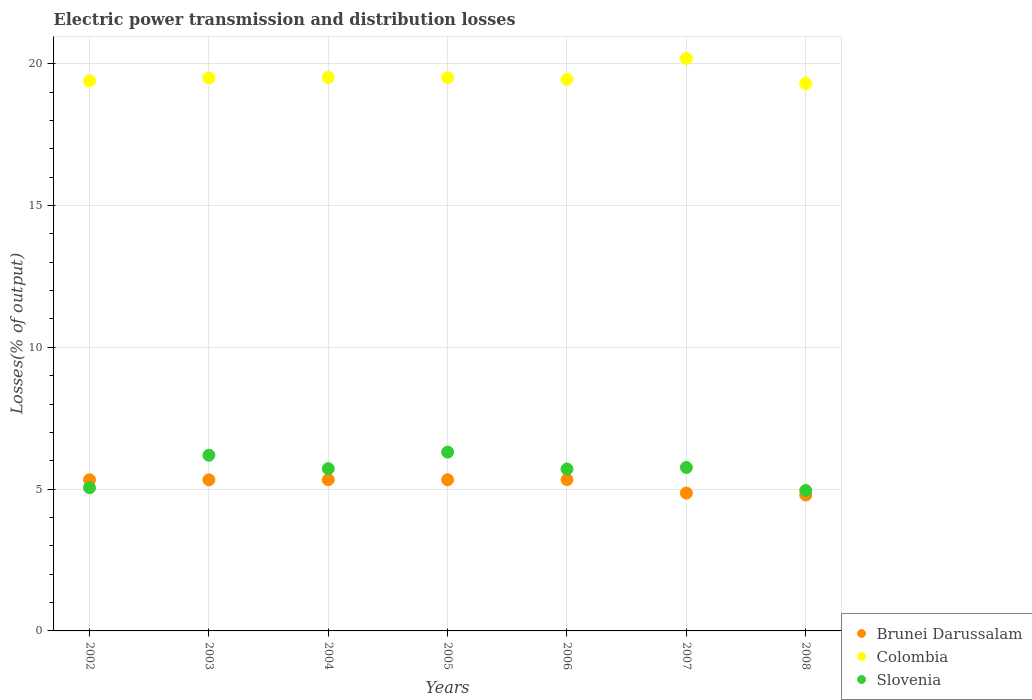How many different coloured dotlines are there?
Provide a short and direct response. 3. Is the number of dotlines equal to the number of legend labels?
Your answer should be compact. Yes. What is the electric power transmission and distribution losses in Colombia in 2007?
Provide a succinct answer. 20.19. Across all years, what is the maximum electric power transmission and distribution losses in Slovenia?
Offer a very short reply. 6.3. Across all years, what is the minimum electric power transmission and distribution losses in Colombia?
Offer a very short reply. 19.3. What is the total electric power transmission and distribution losses in Colombia in the graph?
Your answer should be compact. 136.85. What is the difference between the electric power transmission and distribution losses in Colombia in 2006 and that in 2008?
Provide a short and direct response. 0.14. What is the difference between the electric power transmission and distribution losses in Brunei Darussalam in 2003 and the electric power transmission and distribution losses in Slovenia in 2007?
Your response must be concise. -0.44. What is the average electric power transmission and distribution losses in Slovenia per year?
Make the answer very short. 5.67. In the year 2005, what is the difference between the electric power transmission and distribution losses in Slovenia and electric power transmission and distribution losses in Brunei Darussalam?
Give a very brief answer. 0.97. In how many years, is the electric power transmission and distribution losses in Slovenia greater than 14 %?
Offer a terse response. 0. What is the ratio of the electric power transmission and distribution losses in Colombia in 2002 to that in 2008?
Your answer should be very brief. 1. What is the difference between the highest and the second highest electric power transmission and distribution losses in Slovenia?
Ensure brevity in your answer.  0.11. What is the difference between the highest and the lowest electric power transmission and distribution losses in Colombia?
Your response must be concise. 0.88. Is it the case that in every year, the sum of the electric power transmission and distribution losses in Slovenia and electric power transmission and distribution losses in Brunei Darussalam  is greater than the electric power transmission and distribution losses in Colombia?
Give a very brief answer. No. Is the electric power transmission and distribution losses in Colombia strictly less than the electric power transmission and distribution losses in Slovenia over the years?
Offer a very short reply. No. What is the difference between two consecutive major ticks on the Y-axis?
Give a very brief answer. 5. Are the values on the major ticks of Y-axis written in scientific E-notation?
Make the answer very short. No. Does the graph contain grids?
Your response must be concise. Yes. What is the title of the graph?
Offer a very short reply. Electric power transmission and distribution losses. What is the label or title of the Y-axis?
Your answer should be very brief. Losses(% of output). What is the Losses(% of output) in Brunei Darussalam in 2002?
Keep it short and to the point. 5.33. What is the Losses(% of output) of Colombia in 2002?
Make the answer very short. 19.4. What is the Losses(% of output) of Slovenia in 2002?
Give a very brief answer. 5.05. What is the Losses(% of output) in Brunei Darussalam in 2003?
Offer a terse response. 5.33. What is the Losses(% of output) of Colombia in 2003?
Offer a terse response. 19.49. What is the Losses(% of output) of Slovenia in 2003?
Offer a very short reply. 6.19. What is the Losses(% of output) in Brunei Darussalam in 2004?
Provide a short and direct response. 5.33. What is the Losses(% of output) in Colombia in 2004?
Offer a terse response. 19.52. What is the Losses(% of output) in Slovenia in 2004?
Your response must be concise. 5.72. What is the Losses(% of output) of Brunei Darussalam in 2005?
Your answer should be compact. 5.33. What is the Losses(% of output) of Colombia in 2005?
Offer a terse response. 19.51. What is the Losses(% of output) of Slovenia in 2005?
Ensure brevity in your answer.  6.3. What is the Losses(% of output) of Brunei Darussalam in 2006?
Make the answer very short. 5.34. What is the Losses(% of output) in Colombia in 2006?
Your answer should be very brief. 19.45. What is the Losses(% of output) in Slovenia in 2006?
Your answer should be compact. 5.71. What is the Losses(% of output) in Brunei Darussalam in 2007?
Provide a succinct answer. 4.86. What is the Losses(% of output) of Colombia in 2007?
Your response must be concise. 20.19. What is the Losses(% of output) of Slovenia in 2007?
Keep it short and to the point. 5.76. What is the Losses(% of output) in Brunei Darussalam in 2008?
Offer a very short reply. 4.79. What is the Losses(% of output) in Colombia in 2008?
Offer a very short reply. 19.3. What is the Losses(% of output) of Slovenia in 2008?
Ensure brevity in your answer.  4.95. Across all years, what is the maximum Losses(% of output) of Brunei Darussalam?
Make the answer very short. 5.34. Across all years, what is the maximum Losses(% of output) in Colombia?
Offer a terse response. 20.19. Across all years, what is the maximum Losses(% of output) in Slovenia?
Provide a succinct answer. 6.3. Across all years, what is the minimum Losses(% of output) of Brunei Darussalam?
Give a very brief answer. 4.79. Across all years, what is the minimum Losses(% of output) of Colombia?
Your answer should be compact. 19.3. Across all years, what is the minimum Losses(% of output) of Slovenia?
Provide a succinct answer. 4.95. What is the total Losses(% of output) in Brunei Darussalam in the graph?
Offer a very short reply. 36.31. What is the total Losses(% of output) in Colombia in the graph?
Offer a very short reply. 136.85. What is the total Losses(% of output) in Slovenia in the graph?
Make the answer very short. 39.69. What is the difference between the Losses(% of output) of Brunei Darussalam in 2002 and that in 2003?
Ensure brevity in your answer.  0. What is the difference between the Losses(% of output) of Colombia in 2002 and that in 2003?
Provide a succinct answer. -0.09. What is the difference between the Losses(% of output) in Slovenia in 2002 and that in 2003?
Ensure brevity in your answer.  -1.15. What is the difference between the Losses(% of output) of Colombia in 2002 and that in 2004?
Your answer should be very brief. -0.12. What is the difference between the Losses(% of output) in Slovenia in 2002 and that in 2004?
Provide a succinct answer. -0.67. What is the difference between the Losses(% of output) of Brunei Darussalam in 2002 and that in 2005?
Keep it short and to the point. 0. What is the difference between the Losses(% of output) in Colombia in 2002 and that in 2005?
Keep it short and to the point. -0.11. What is the difference between the Losses(% of output) in Slovenia in 2002 and that in 2005?
Ensure brevity in your answer.  -1.26. What is the difference between the Losses(% of output) in Brunei Darussalam in 2002 and that in 2006?
Your response must be concise. -0.01. What is the difference between the Losses(% of output) of Colombia in 2002 and that in 2006?
Offer a very short reply. -0.05. What is the difference between the Losses(% of output) in Slovenia in 2002 and that in 2006?
Provide a succinct answer. -0.66. What is the difference between the Losses(% of output) in Brunei Darussalam in 2002 and that in 2007?
Offer a very short reply. 0.47. What is the difference between the Losses(% of output) of Colombia in 2002 and that in 2007?
Your answer should be very brief. -0.79. What is the difference between the Losses(% of output) of Slovenia in 2002 and that in 2007?
Give a very brief answer. -0.71. What is the difference between the Losses(% of output) of Brunei Darussalam in 2002 and that in 2008?
Offer a very short reply. 0.54. What is the difference between the Losses(% of output) of Colombia in 2002 and that in 2008?
Keep it short and to the point. 0.09. What is the difference between the Losses(% of output) in Slovenia in 2002 and that in 2008?
Ensure brevity in your answer.  0.1. What is the difference between the Losses(% of output) of Brunei Darussalam in 2003 and that in 2004?
Keep it short and to the point. -0. What is the difference between the Losses(% of output) of Colombia in 2003 and that in 2004?
Offer a very short reply. -0.03. What is the difference between the Losses(% of output) of Slovenia in 2003 and that in 2004?
Provide a succinct answer. 0.47. What is the difference between the Losses(% of output) of Brunei Darussalam in 2003 and that in 2005?
Ensure brevity in your answer.  -0. What is the difference between the Losses(% of output) of Colombia in 2003 and that in 2005?
Ensure brevity in your answer.  -0.02. What is the difference between the Losses(% of output) of Slovenia in 2003 and that in 2005?
Provide a succinct answer. -0.11. What is the difference between the Losses(% of output) in Brunei Darussalam in 2003 and that in 2006?
Offer a terse response. -0.01. What is the difference between the Losses(% of output) of Colombia in 2003 and that in 2006?
Offer a very short reply. 0.04. What is the difference between the Losses(% of output) of Slovenia in 2003 and that in 2006?
Keep it short and to the point. 0.48. What is the difference between the Losses(% of output) of Brunei Darussalam in 2003 and that in 2007?
Your answer should be very brief. 0.47. What is the difference between the Losses(% of output) in Colombia in 2003 and that in 2007?
Keep it short and to the point. -0.7. What is the difference between the Losses(% of output) of Slovenia in 2003 and that in 2007?
Provide a short and direct response. 0.43. What is the difference between the Losses(% of output) of Brunei Darussalam in 2003 and that in 2008?
Keep it short and to the point. 0.54. What is the difference between the Losses(% of output) in Colombia in 2003 and that in 2008?
Ensure brevity in your answer.  0.19. What is the difference between the Losses(% of output) in Slovenia in 2003 and that in 2008?
Provide a succinct answer. 1.24. What is the difference between the Losses(% of output) in Colombia in 2004 and that in 2005?
Ensure brevity in your answer.  0.01. What is the difference between the Losses(% of output) in Slovenia in 2004 and that in 2005?
Offer a very short reply. -0.58. What is the difference between the Losses(% of output) of Brunei Darussalam in 2004 and that in 2006?
Provide a short and direct response. -0.01. What is the difference between the Losses(% of output) in Colombia in 2004 and that in 2006?
Offer a terse response. 0.07. What is the difference between the Losses(% of output) of Slovenia in 2004 and that in 2006?
Offer a terse response. 0.01. What is the difference between the Losses(% of output) of Brunei Darussalam in 2004 and that in 2007?
Make the answer very short. 0.47. What is the difference between the Losses(% of output) in Colombia in 2004 and that in 2007?
Your answer should be compact. -0.67. What is the difference between the Losses(% of output) of Slovenia in 2004 and that in 2007?
Keep it short and to the point. -0.04. What is the difference between the Losses(% of output) in Brunei Darussalam in 2004 and that in 2008?
Provide a succinct answer. 0.54. What is the difference between the Losses(% of output) of Colombia in 2004 and that in 2008?
Offer a very short reply. 0.21. What is the difference between the Losses(% of output) in Slovenia in 2004 and that in 2008?
Make the answer very short. 0.77. What is the difference between the Losses(% of output) of Brunei Darussalam in 2005 and that in 2006?
Provide a succinct answer. -0.01. What is the difference between the Losses(% of output) of Colombia in 2005 and that in 2006?
Ensure brevity in your answer.  0.06. What is the difference between the Losses(% of output) in Slovenia in 2005 and that in 2006?
Provide a short and direct response. 0.59. What is the difference between the Losses(% of output) of Brunei Darussalam in 2005 and that in 2007?
Your answer should be very brief. 0.47. What is the difference between the Losses(% of output) of Colombia in 2005 and that in 2007?
Your answer should be compact. -0.68. What is the difference between the Losses(% of output) in Slovenia in 2005 and that in 2007?
Give a very brief answer. 0.54. What is the difference between the Losses(% of output) in Brunei Darussalam in 2005 and that in 2008?
Offer a terse response. 0.54. What is the difference between the Losses(% of output) of Colombia in 2005 and that in 2008?
Your response must be concise. 0.2. What is the difference between the Losses(% of output) of Slovenia in 2005 and that in 2008?
Your answer should be compact. 1.35. What is the difference between the Losses(% of output) in Brunei Darussalam in 2006 and that in 2007?
Your response must be concise. 0.48. What is the difference between the Losses(% of output) of Colombia in 2006 and that in 2007?
Make the answer very short. -0.74. What is the difference between the Losses(% of output) of Slovenia in 2006 and that in 2007?
Make the answer very short. -0.05. What is the difference between the Losses(% of output) in Brunei Darussalam in 2006 and that in 2008?
Make the answer very short. 0.55. What is the difference between the Losses(% of output) of Colombia in 2006 and that in 2008?
Provide a succinct answer. 0.14. What is the difference between the Losses(% of output) in Slovenia in 2006 and that in 2008?
Make the answer very short. 0.76. What is the difference between the Losses(% of output) of Brunei Darussalam in 2007 and that in 2008?
Your answer should be very brief. 0.07. What is the difference between the Losses(% of output) of Colombia in 2007 and that in 2008?
Make the answer very short. 0.88. What is the difference between the Losses(% of output) of Slovenia in 2007 and that in 2008?
Provide a succinct answer. 0.81. What is the difference between the Losses(% of output) of Brunei Darussalam in 2002 and the Losses(% of output) of Colombia in 2003?
Your answer should be very brief. -14.16. What is the difference between the Losses(% of output) in Brunei Darussalam in 2002 and the Losses(% of output) in Slovenia in 2003?
Provide a short and direct response. -0.86. What is the difference between the Losses(% of output) of Colombia in 2002 and the Losses(% of output) of Slovenia in 2003?
Offer a very short reply. 13.2. What is the difference between the Losses(% of output) in Brunei Darussalam in 2002 and the Losses(% of output) in Colombia in 2004?
Your response must be concise. -14.19. What is the difference between the Losses(% of output) in Brunei Darussalam in 2002 and the Losses(% of output) in Slovenia in 2004?
Provide a succinct answer. -0.39. What is the difference between the Losses(% of output) of Colombia in 2002 and the Losses(% of output) of Slovenia in 2004?
Your response must be concise. 13.67. What is the difference between the Losses(% of output) in Brunei Darussalam in 2002 and the Losses(% of output) in Colombia in 2005?
Ensure brevity in your answer.  -14.18. What is the difference between the Losses(% of output) in Brunei Darussalam in 2002 and the Losses(% of output) in Slovenia in 2005?
Ensure brevity in your answer.  -0.97. What is the difference between the Losses(% of output) of Colombia in 2002 and the Losses(% of output) of Slovenia in 2005?
Offer a terse response. 13.09. What is the difference between the Losses(% of output) of Brunei Darussalam in 2002 and the Losses(% of output) of Colombia in 2006?
Your answer should be compact. -14.11. What is the difference between the Losses(% of output) of Brunei Darussalam in 2002 and the Losses(% of output) of Slovenia in 2006?
Your response must be concise. -0.38. What is the difference between the Losses(% of output) in Colombia in 2002 and the Losses(% of output) in Slovenia in 2006?
Offer a terse response. 13.69. What is the difference between the Losses(% of output) of Brunei Darussalam in 2002 and the Losses(% of output) of Colombia in 2007?
Offer a terse response. -14.86. What is the difference between the Losses(% of output) of Brunei Darussalam in 2002 and the Losses(% of output) of Slovenia in 2007?
Ensure brevity in your answer.  -0.43. What is the difference between the Losses(% of output) of Colombia in 2002 and the Losses(% of output) of Slovenia in 2007?
Offer a very short reply. 13.63. What is the difference between the Losses(% of output) in Brunei Darussalam in 2002 and the Losses(% of output) in Colombia in 2008?
Give a very brief answer. -13.97. What is the difference between the Losses(% of output) of Brunei Darussalam in 2002 and the Losses(% of output) of Slovenia in 2008?
Offer a terse response. 0.38. What is the difference between the Losses(% of output) of Colombia in 2002 and the Losses(% of output) of Slovenia in 2008?
Your answer should be very brief. 14.45. What is the difference between the Losses(% of output) of Brunei Darussalam in 2003 and the Losses(% of output) of Colombia in 2004?
Your answer should be compact. -14.19. What is the difference between the Losses(% of output) of Brunei Darussalam in 2003 and the Losses(% of output) of Slovenia in 2004?
Provide a succinct answer. -0.4. What is the difference between the Losses(% of output) of Colombia in 2003 and the Losses(% of output) of Slovenia in 2004?
Ensure brevity in your answer.  13.77. What is the difference between the Losses(% of output) of Brunei Darussalam in 2003 and the Losses(% of output) of Colombia in 2005?
Your response must be concise. -14.18. What is the difference between the Losses(% of output) of Brunei Darussalam in 2003 and the Losses(% of output) of Slovenia in 2005?
Ensure brevity in your answer.  -0.98. What is the difference between the Losses(% of output) in Colombia in 2003 and the Losses(% of output) in Slovenia in 2005?
Offer a very short reply. 13.19. What is the difference between the Losses(% of output) of Brunei Darussalam in 2003 and the Losses(% of output) of Colombia in 2006?
Your answer should be very brief. -14.12. What is the difference between the Losses(% of output) of Brunei Darussalam in 2003 and the Losses(% of output) of Slovenia in 2006?
Your response must be concise. -0.38. What is the difference between the Losses(% of output) in Colombia in 2003 and the Losses(% of output) in Slovenia in 2006?
Keep it short and to the point. 13.78. What is the difference between the Losses(% of output) of Brunei Darussalam in 2003 and the Losses(% of output) of Colombia in 2007?
Make the answer very short. -14.86. What is the difference between the Losses(% of output) in Brunei Darussalam in 2003 and the Losses(% of output) in Slovenia in 2007?
Keep it short and to the point. -0.44. What is the difference between the Losses(% of output) of Colombia in 2003 and the Losses(% of output) of Slovenia in 2007?
Ensure brevity in your answer.  13.73. What is the difference between the Losses(% of output) in Brunei Darussalam in 2003 and the Losses(% of output) in Colombia in 2008?
Ensure brevity in your answer.  -13.98. What is the difference between the Losses(% of output) of Brunei Darussalam in 2003 and the Losses(% of output) of Slovenia in 2008?
Offer a terse response. 0.38. What is the difference between the Losses(% of output) in Colombia in 2003 and the Losses(% of output) in Slovenia in 2008?
Your response must be concise. 14.54. What is the difference between the Losses(% of output) of Brunei Darussalam in 2004 and the Losses(% of output) of Colombia in 2005?
Your answer should be compact. -14.18. What is the difference between the Losses(% of output) of Brunei Darussalam in 2004 and the Losses(% of output) of Slovenia in 2005?
Your answer should be compact. -0.97. What is the difference between the Losses(% of output) in Colombia in 2004 and the Losses(% of output) in Slovenia in 2005?
Give a very brief answer. 13.21. What is the difference between the Losses(% of output) in Brunei Darussalam in 2004 and the Losses(% of output) in Colombia in 2006?
Ensure brevity in your answer.  -14.11. What is the difference between the Losses(% of output) of Brunei Darussalam in 2004 and the Losses(% of output) of Slovenia in 2006?
Offer a very short reply. -0.38. What is the difference between the Losses(% of output) of Colombia in 2004 and the Losses(% of output) of Slovenia in 2006?
Your answer should be compact. 13.81. What is the difference between the Losses(% of output) of Brunei Darussalam in 2004 and the Losses(% of output) of Colombia in 2007?
Provide a succinct answer. -14.86. What is the difference between the Losses(% of output) of Brunei Darussalam in 2004 and the Losses(% of output) of Slovenia in 2007?
Keep it short and to the point. -0.43. What is the difference between the Losses(% of output) of Colombia in 2004 and the Losses(% of output) of Slovenia in 2007?
Provide a succinct answer. 13.75. What is the difference between the Losses(% of output) of Brunei Darussalam in 2004 and the Losses(% of output) of Colombia in 2008?
Provide a short and direct response. -13.97. What is the difference between the Losses(% of output) in Brunei Darussalam in 2004 and the Losses(% of output) in Slovenia in 2008?
Give a very brief answer. 0.38. What is the difference between the Losses(% of output) in Colombia in 2004 and the Losses(% of output) in Slovenia in 2008?
Give a very brief answer. 14.57. What is the difference between the Losses(% of output) in Brunei Darussalam in 2005 and the Losses(% of output) in Colombia in 2006?
Keep it short and to the point. -14.11. What is the difference between the Losses(% of output) of Brunei Darussalam in 2005 and the Losses(% of output) of Slovenia in 2006?
Offer a very short reply. -0.38. What is the difference between the Losses(% of output) of Colombia in 2005 and the Losses(% of output) of Slovenia in 2006?
Offer a terse response. 13.8. What is the difference between the Losses(% of output) in Brunei Darussalam in 2005 and the Losses(% of output) in Colombia in 2007?
Provide a short and direct response. -14.86. What is the difference between the Losses(% of output) in Brunei Darussalam in 2005 and the Losses(% of output) in Slovenia in 2007?
Keep it short and to the point. -0.43. What is the difference between the Losses(% of output) in Colombia in 2005 and the Losses(% of output) in Slovenia in 2007?
Ensure brevity in your answer.  13.74. What is the difference between the Losses(% of output) of Brunei Darussalam in 2005 and the Losses(% of output) of Colombia in 2008?
Your answer should be very brief. -13.97. What is the difference between the Losses(% of output) of Brunei Darussalam in 2005 and the Losses(% of output) of Slovenia in 2008?
Your answer should be very brief. 0.38. What is the difference between the Losses(% of output) of Colombia in 2005 and the Losses(% of output) of Slovenia in 2008?
Offer a very short reply. 14.55. What is the difference between the Losses(% of output) in Brunei Darussalam in 2006 and the Losses(% of output) in Colombia in 2007?
Make the answer very short. -14.85. What is the difference between the Losses(% of output) of Brunei Darussalam in 2006 and the Losses(% of output) of Slovenia in 2007?
Offer a terse response. -0.43. What is the difference between the Losses(% of output) in Colombia in 2006 and the Losses(% of output) in Slovenia in 2007?
Offer a very short reply. 13.68. What is the difference between the Losses(% of output) of Brunei Darussalam in 2006 and the Losses(% of output) of Colombia in 2008?
Provide a succinct answer. -13.97. What is the difference between the Losses(% of output) of Brunei Darussalam in 2006 and the Losses(% of output) of Slovenia in 2008?
Your answer should be compact. 0.39. What is the difference between the Losses(% of output) of Colombia in 2006 and the Losses(% of output) of Slovenia in 2008?
Your answer should be very brief. 14.49. What is the difference between the Losses(% of output) in Brunei Darussalam in 2007 and the Losses(% of output) in Colombia in 2008?
Provide a short and direct response. -14.44. What is the difference between the Losses(% of output) in Brunei Darussalam in 2007 and the Losses(% of output) in Slovenia in 2008?
Your answer should be very brief. -0.09. What is the difference between the Losses(% of output) of Colombia in 2007 and the Losses(% of output) of Slovenia in 2008?
Provide a short and direct response. 15.24. What is the average Losses(% of output) of Brunei Darussalam per year?
Your answer should be compact. 5.19. What is the average Losses(% of output) of Colombia per year?
Your answer should be compact. 19.55. What is the average Losses(% of output) of Slovenia per year?
Ensure brevity in your answer.  5.67. In the year 2002, what is the difference between the Losses(% of output) in Brunei Darussalam and Losses(% of output) in Colombia?
Give a very brief answer. -14.07. In the year 2002, what is the difference between the Losses(% of output) of Brunei Darussalam and Losses(% of output) of Slovenia?
Ensure brevity in your answer.  0.28. In the year 2002, what is the difference between the Losses(% of output) in Colombia and Losses(% of output) in Slovenia?
Make the answer very short. 14.35. In the year 2003, what is the difference between the Losses(% of output) in Brunei Darussalam and Losses(% of output) in Colombia?
Provide a short and direct response. -14.16. In the year 2003, what is the difference between the Losses(% of output) of Brunei Darussalam and Losses(% of output) of Slovenia?
Ensure brevity in your answer.  -0.87. In the year 2003, what is the difference between the Losses(% of output) of Colombia and Losses(% of output) of Slovenia?
Keep it short and to the point. 13.3. In the year 2004, what is the difference between the Losses(% of output) in Brunei Darussalam and Losses(% of output) in Colombia?
Ensure brevity in your answer.  -14.19. In the year 2004, what is the difference between the Losses(% of output) in Brunei Darussalam and Losses(% of output) in Slovenia?
Your answer should be compact. -0.39. In the year 2004, what is the difference between the Losses(% of output) in Colombia and Losses(% of output) in Slovenia?
Your answer should be compact. 13.79. In the year 2005, what is the difference between the Losses(% of output) in Brunei Darussalam and Losses(% of output) in Colombia?
Ensure brevity in your answer.  -14.18. In the year 2005, what is the difference between the Losses(% of output) of Brunei Darussalam and Losses(% of output) of Slovenia?
Make the answer very short. -0.97. In the year 2005, what is the difference between the Losses(% of output) of Colombia and Losses(% of output) of Slovenia?
Keep it short and to the point. 13.2. In the year 2006, what is the difference between the Losses(% of output) of Brunei Darussalam and Losses(% of output) of Colombia?
Offer a terse response. -14.11. In the year 2006, what is the difference between the Losses(% of output) of Brunei Darussalam and Losses(% of output) of Slovenia?
Make the answer very short. -0.37. In the year 2006, what is the difference between the Losses(% of output) in Colombia and Losses(% of output) in Slovenia?
Provide a short and direct response. 13.74. In the year 2007, what is the difference between the Losses(% of output) in Brunei Darussalam and Losses(% of output) in Colombia?
Your answer should be very brief. -15.33. In the year 2007, what is the difference between the Losses(% of output) in Brunei Darussalam and Losses(% of output) in Slovenia?
Your answer should be very brief. -0.9. In the year 2007, what is the difference between the Losses(% of output) in Colombia and Losses(% of output) in Slovenia?
Offer a terse response. 14.42. In the year 2008, what is the difference between the Losses(% of output) in Brunei Darussalam and Losses(% of output) in Colombia?
Make the answer very short. -14.51. In the year 2008, what is the difference between the Losses(% of output) in Brunei Darussalam and Losses(% of output) in Slovenia?
Your response must be concise. -0.16. In the year 2008, what is the difference between the Losses(% of output) in Colombia and Losses(% of output) in Slovenia?
Keep it short and to the point. 14.35. What is the ratio of the Losses(% of output) of Slovenia in 2002 to that in 2003?
Give a very brief answer. 0.82. What is the ratio of the Losses(% of output) of Colombia in 2002 to that in 2004?
Make the answer very short. 0.99. What is the ratio of the Losses(% of output) of Slovenia in 2002 to that in 2004?
Ensure brevity in your answer.  0.88. What is the ratio of the Losses(% of output) of Colombia in 2002 to that in 2005?
Offer a very short reply. 0.99. What is the ratio of the Losses(% of output) of Slovenia in 2002 to that in 2005?
Offer a terse response. 0.8. What is the ratio of the Losses(% of output) in Colombia in 2002 to that in 2006?
Your answer should be compact. 1. What is the ratio of the Losses(% of output) of Slovenia in 2002 to that in 2006?
Your answer should be compact. 0.88. What is the ratio of the Losses(% of output) of Brunei Darussalam in 2002 to that in 2007?
Your response must be concise. 1.1. What is the ratio of the Losses(% of output) in Colombia in 2002 to that in 2007?
Ensure brevity in your answer.  0.96. What is the ratio of the Losses(% of output) in Slovenia in 2002 to that in 2007?
Give a very brief answer. 0.88. What is the ratio of the Losses(% of output) in Brunei Darussalam in 2002 to that in 2008?
Offer a terse response. 1.11. What is the ratio of the Losses(% of output) of Colombia in 2002 to that in 2008?
Provide a succinct answer. 1. What is the ratio of the Losses(% of output) of Slovenia in 2002 to that in 2008?
Make the answer very short. 1.02. What is the ratio of the Losses(% of output) of Colombia in 2003 to that in 2004?
Keep it short and to the point. 1. What is the ratio of the Losses(% of output) of Slovenia in 2003 to that in 2004?
Your answer should be compact. 1.08. What is the ratio of the Losses(% of output) of Slovenia in 2003 to that in 2005?
Provide a succinct answer. 0.98. What is the ratio of the Losses(% of output) of Colombia in 2003 to that in 2006?
Make the answer very short. 1. What is the ratio of the Losses(% of output) of Slovenia in 2003 to that in 2006?
Make the answer very short. 1.08. What is the ratio of the Losses(% of output) of Brunei Darussalam in 2003 to that in 2007?
Give a very brief answer. 1.1. What is the ratio of the Losses(% of output) in Colombia in 2003 to that in 2007?
Make the answer very short. 0.97. What is the ratio of the Losses(% of output) in Slovenia in 2003 to that in 2007?
Provide a short and direct response. 1.07. What is the ratio of the Losses(% of output) of Brunei Darussalam in 2003 to that in 2008?
Ensure brevity in your answer.  1.11. What is the ratio of the Losses(% of output) of Colombia in 2003 to that in 2008?
Give a very brief answer. 1.01. What is the ratio of the Losses(% of output) in Slovenia in 2003 to that in 2008?
Provide a succinct answer. 1.25. What is the ratio of the Losses(% of output) of Brunei Darussalam in 2004 to that in 2005?
Your answer should be compact. 1. What is the ratio of the Losses(% of output) in Colombia in 2004 to that in 2005?
Your response must be concise. 1. What is the ratio of the Losses(% of output) in Slovenia in 2004 to that in 2005?
Keep it short and to the point. 0.91. What is the ratio of the Losses(% of output) of Brunei Darussalam in 2004 to that in 2006?
Offer a terse response. 1. What is the ratio of the Losses(% of output) of Slovenia in 2004 to that in 2006?
Give a very brief answer. 1. What is the ratio of the Losses(% of output) in Brunei Darussalam in 2004 to that in 2007?
Keep it short and to the point. 1.1. What is the ratio of the Losses(% of output) in Colombia in 2004 to that in 2007?
Your answer should be very brief. 0.97. What is the ratio of the Losses(% of output) of Brunei Darussalam in 2004 to that in 2008?
Ensure brevity in your answer.  1.11. What is the ratio of the Losses(% of output) of Colombia in 2004 to that in 2008?
Your response must be concise. 1.01. What is the ratio of the Losses(% of output) of Slovenia in 2004 to that in 2008?
Your answer should be compact. 1.16. What is the ratio of the Losses(% of output) of Brunei Darussalam in 2005 to that in 2006?
Your answer should be very brief. 1. What is the ratio of the Losses(% of output) of Slovenia in 2005 to that in 2006?
Provide a succinct answer. 1.1. What is the ratio of the Losses(% of output) in Brunei Darussalam in 2005 to that in 2007?
Provide a succinct answer. 1.1. What is the ratio of the Losses(% of output) of Colombia in 2005 to that in 2007?
Keep it short and to the point. 0.97. What is the ratio of the Losses(% of output) of Slovenia in 2005 to that in 2007?
Offer a terse response. 1.09. What is the ratio of the Losses(% of output) in Brunei Darussalam in 2005 to that in 2008?
Ensure brevity in your answer.  1.11. What is the ratio of the Losses(% of output) of Colombia in 2005 to that in 2008?
Make the answer very short. 1.01. What is the ratio of the Losses(% of output) of Slovenia in 2005 to that in 2008?
Provide a succinct answer. 1.27. What is the ratio of the Losses(% of output) in Brunei Darussalam in 2006 to that in 2007?
Your answer should be very brief. 1.1. What is the ratio of the Losses(% of output) of Colombia in 2006 to that in 2007?
Your answer should be very brief. 0.96. What is the ratio of the Losses(% of output) in Slovenia in 2006 to that in 2007?
Offer a very short reply. 0.99. What is the ratio of the Losses(% of output) of Brunei Darussalam in 2006 to that in 2008?
Make the answer very short. 1.11. What is the ratio of the Losses(% of output) in Colombia in 2006 to that in 2008?
Offer a very short reply. 1.01. What is the ratio of the Losses(% of output) of Slovenia in 2006 to that in 2008?
Make the answer very short. 1.15. What is the ratio of the Losses(% of output) of Brunei Darussalam in 2007 to that in 2008?
Your response must be concise. 1.01. What is the ratio of the Losses(% of output) of Colombia in 2007 to that in 2008?
Give a very brief answer. 1.05. What is the ratio of the Losses(% of output) of Slovenia in 2007 to that in 2008?
Offer a very short reply. 1.16. What is the difference between the highest and the second highest Losses(% of output) in Brunei Darussalam?
Provide a succinct answer. 0.01. What is the difference between the highest and the second highest Losses(% of output) of Colombia?
Offer a very short reply. 0.67. What is the difference between the highest and the second highest Losses(% of output) in Slovenia?
Make the answer very short. 0.11. What is the difference between the highest and the lowest Losses(% of output) of Brunei Darussalam?
Offer a terse response. 0.55. What is the difference between the highest and the lowest Losses(% of output) in Colombia?
Keep it short and to the point. 0.88. What is the difference between the highest and the lowest Losses(% of output) in Slovenia?
Provide a succinct answer. 1.35. 